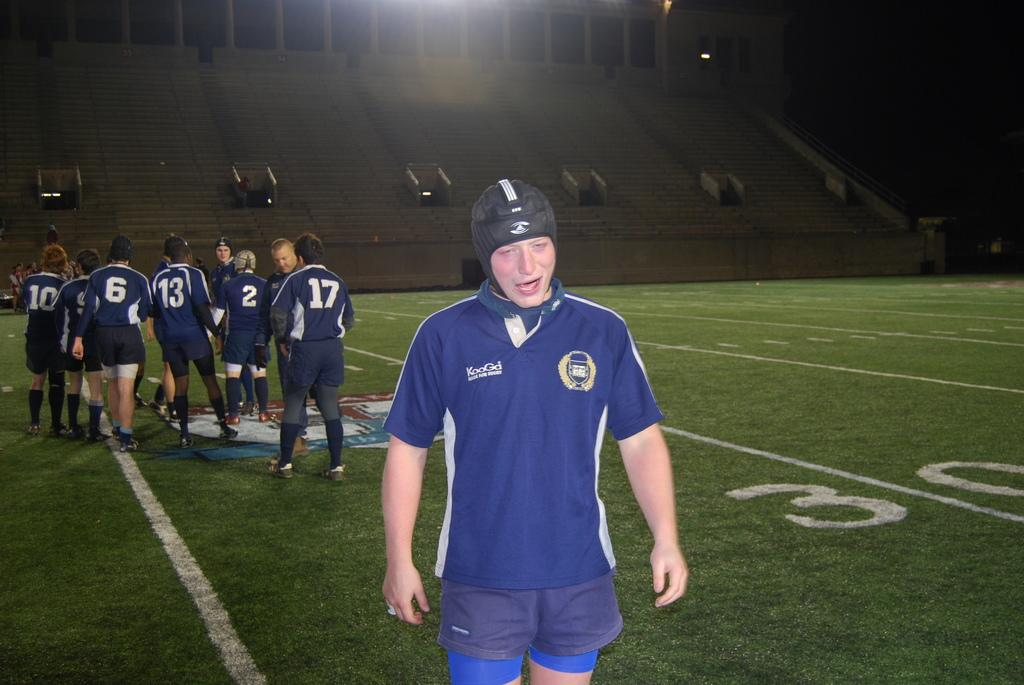<image>
Relay a brief, clear account of the picture shown. A group of soccer players are huddled in the field and one player is away from the group and his shirt says KooGd. 